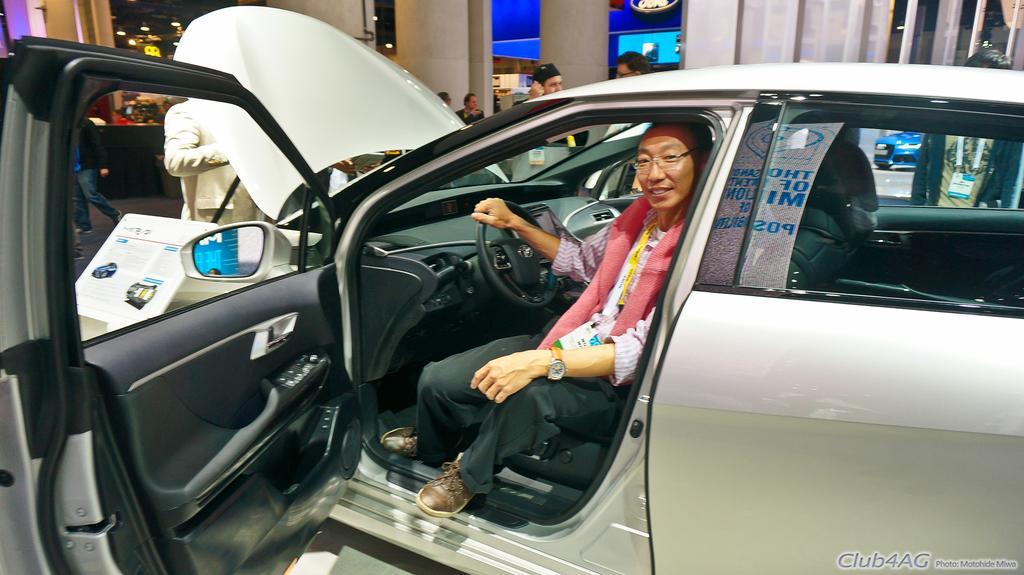How would you summarize this image in a sentence or two? This picture shows and a human seated and I can see car bonnet and a door is opened and I can see few people standing on the side, it looks like a car showroom from the car glass, I can see another car in the back and I can see text at the bottom right corner of the picture. 